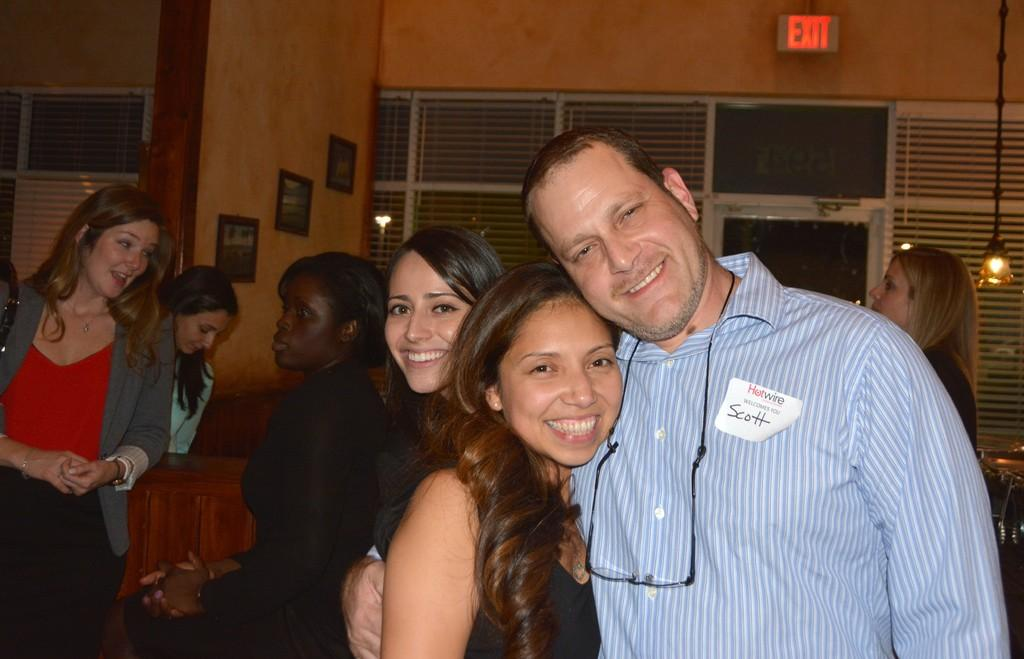What is happening with the group of people in the image? Most of the people are laughing in the image. Can you describe any symbols or signs in the image? There is an exit symbol in the top right corner of the image. What can be seen on the wall in the image? There are portraits on the wall in the image. How many babies are visible in the image? There are no babies present in the image. What color is the sock on the person's foot in the image? There is no sock visible on anyone's foot in the image. 